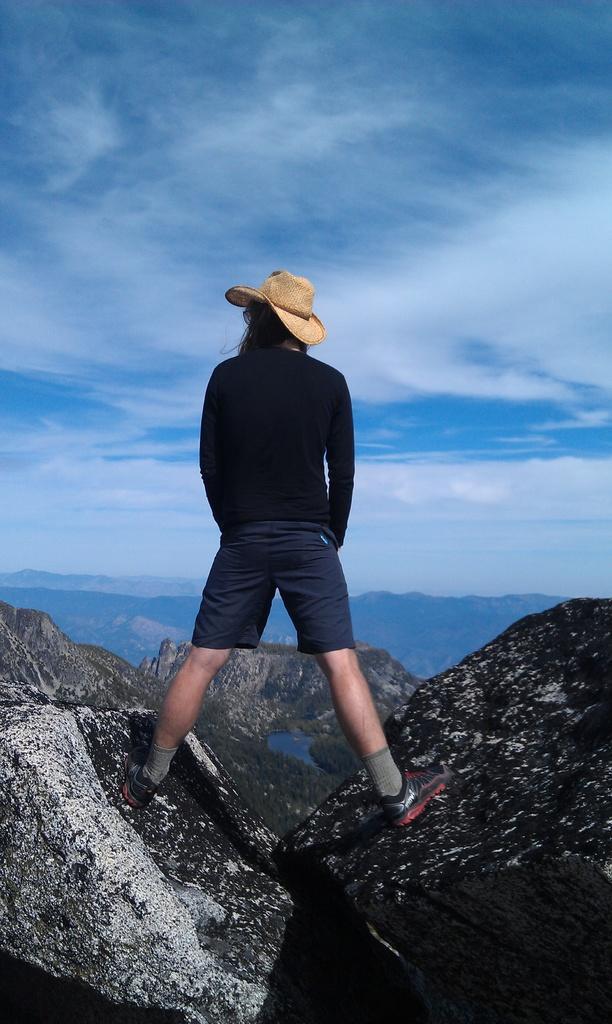How would you summarize this image in a sentence or two? In this picture we can see a person with a hat. In front of the person they are hills, trees and the sky. 